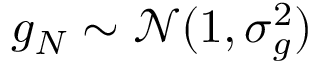Convert formula to latex. <formula><loc_0><loc_0><loc_500><loc_500>g _ { N } \sim \mathcal { N } ( 1 , \sigma _ { g } ^ { 2 } )</formula> 